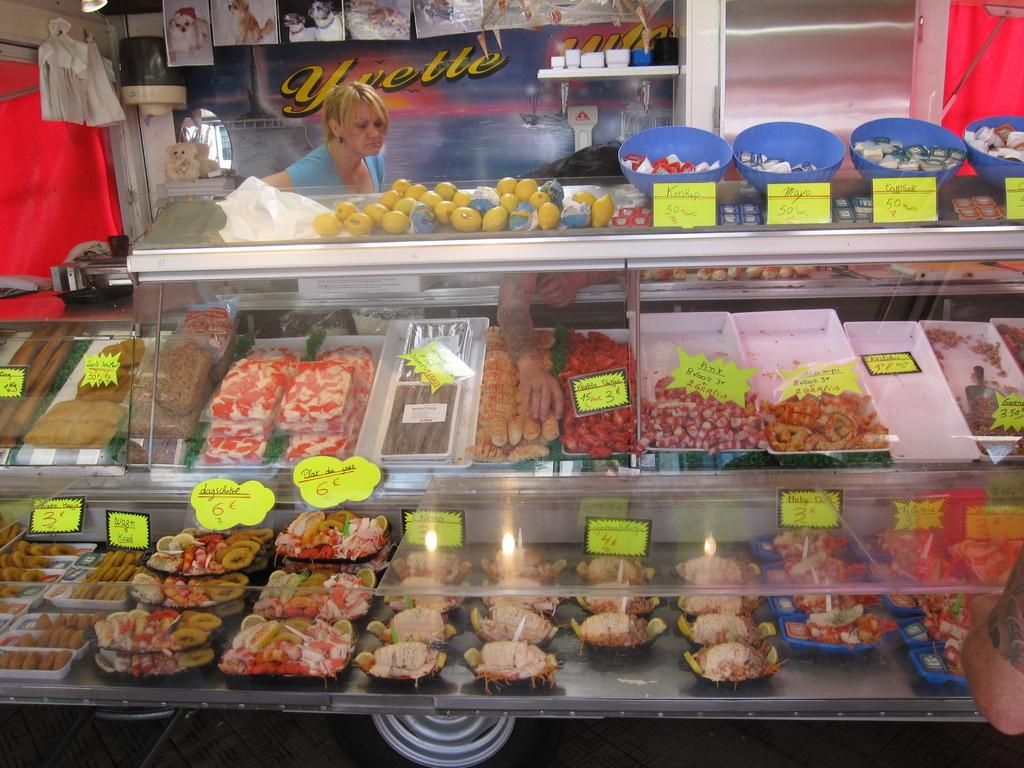<image>
Provide a brief description of the given image. A female store clerk is standing behind a stand with a poster with the word yvette visible behind her. 